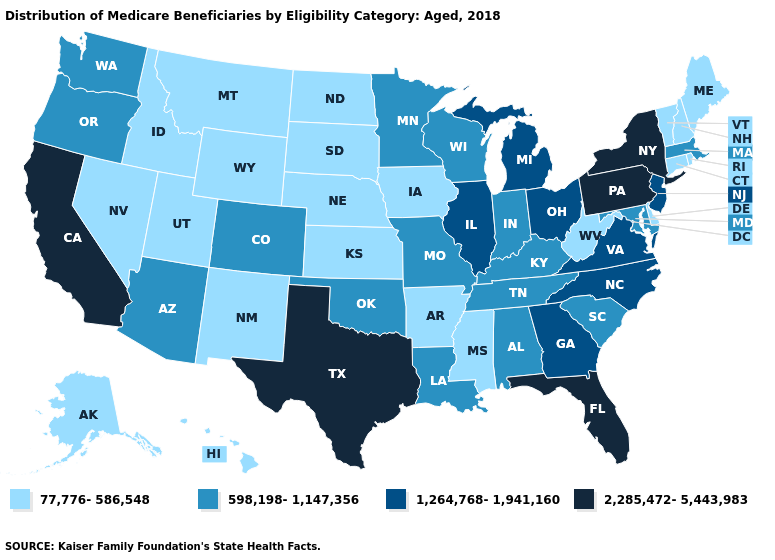What is the value of Indiana?
Concise answer only. 598,198-1,147,356. Which states have the highest value in the USA?
Write a very short answer. California, Florida, New York, Pennsylvania, Texas. Does the map have missing data?
Give a very brief answer. No. What is the value of Hawaii?
Quick response, please. 77,776-586,548. Which states have the highest value in the USA?
Write a very short answer. California, Florida, New York, Pennsylvania, Texas. Name the states that have a value in the range 598,198-1,147,356?
Concise answer only. Alabama, Arizona, Colorado, Indiana, Kentucky, Louisiana, Maryland, Massachusetts, Minnesota, Missouri, Oklahoma, Oregon, South Carolina, Tennessee, Washington, Wisconsin. What is the value of Utah?
Short answer required. 77,776-586,548. Does New Jersey have the highest value in the USA?
Be succinct. No. Among the states that border Oklahoma , does Texas have the lowest value?
Be succinct. No. What is the value of Indiana?
Short answer required. 598,198-1,147,356. Does Alaska have the highest value in the USA?
Quick response, please. No. Among the states that border Illinois , which have the lowest value?
Concise answer only. Iowa. Name the states that have a value in the range 598,198-1,147,356?
Keep it brief. Alabama, Arizona, Colorado, Indiana, Kentucky, Louisiana, Maryland, Massachusetts, Minnesota, Missouri, Oklahoma, Oregon, South Carolina, Tennessee, Washington, Wisconsin. What is the value of Mississippi?
Answer briefly. 77,776-586,548. Name the states that have a value in the range 598,198-1,147,356?
Write a very short answer. Alabama, Arizona, Colorado, Indiana, Kentucky, Louisiana, Maryland, Massachusetts, Minnesota, Missouri, Oklahoma, Oregon, South Carolina, Tennessee, Washington, Wisconsin. 